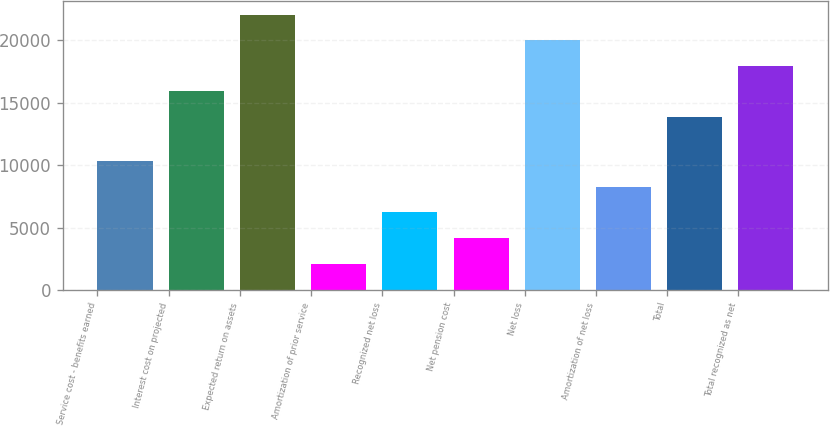<chart> <loc_0><loc_0><loc_500><loc_500><bar_chart><fcel>Service cost - benefits earned<fcel>Interest cost on projected<fcel>Expected return on assets<fcel>Amortization of prior service<fcel>Recognized net loss<fcel>Net pension cost<fcel>Net loss<fcel>Amortization of net loss<fcel>Total<fcel>Total recognized as net<nl><fcel>10307<fcel>15919.4<fcel>22064.6<fcel>2113.4<fcel>6210.2<fcel>4161.8<fcel>20016.2<fcel>8258.6<fcel>13871<fcel>17967.8<nl></chart> 